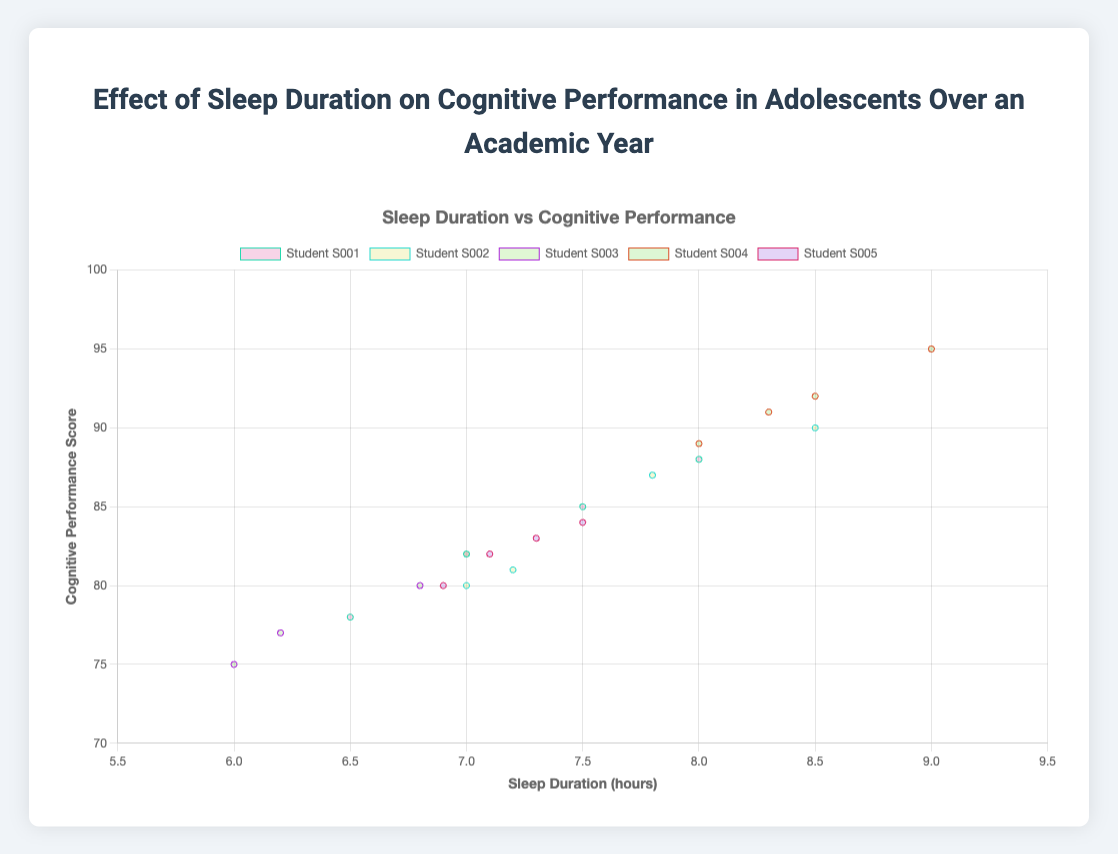What is the average sleep duration for Student S001 across the months? To find the average sleep duration, add the sleep durations for Student S001 (7.5, 7.0, 6.5, 8.0) and divide by the number of months (4). The sum is 29.0. The average is 29.0 / 4 = 7.25 hours.
Answer: 7.25 hours Which student has the highest cognitive performance score in November? By examining the data points for November, Student S004 has the highest score of 89.
Answer: Student S004 What is the difference in cognitive performance scores between Student S003 and Student S005 in December? The cognitive performance scores for Student S003 and Student S005 in December are 82 and 82, respectively. Hence, the difference is 82 - 82 = 0.
Answer: 0 Which student shows the greatest improvement in cognitive performance from September to December? To determine this, calculate the difference in cognitive performance scores between September and December for each student: S001 (+3), S002 (-9), S003 (+7), S004 (-4), S005 (-2). Student S003 shows the greatest improvement.
Answer: Student S003 Across the months, which student had the most consistent sleep duration? To identify the most consistent sleep duration, calculate the range (maximum - minimum sleep duration) for each student: S001 (1.5), S002 (1.5), S003 (1.0), S004 (1.0), S005 (0.6). Student S005 has the smallest range of 0.6 hours.
Answer: Student S005 Which student had the lowest cognitive performance score and in which month? Student S003 had the lowest cognitive performance score of 75 in September.
Answer: Student S003 in September Which month had the highest average cognitive performance score? To find this, calculate the average cognitive performance score for each month: September (85.8), October (84.2), November (81.4), December (84.8). The highest average is 85.8 in September.
Answer: September How many students have a cognitive performance score of 80 or above in October? In October, the cognitive performance scores of the students are 82, 87, 77, 92, and 83. Four students have scores of 80 or above.
Answer: 4 students What is the average cognitive performance score of Student S002 over the academic year? To find the average, add the cognitive performance scores of Student S002 (90, 87, 80, 81) and divide by the number of months (4). The sum is 338. The average is 338 / 4 = 84.5.
Answer: 84.5 Is there a student whose cognitive performance decreased every month? By comparing the cognitive performance scores month over month for each student, none of the students consistently show a decrease every month.
Answer: No 